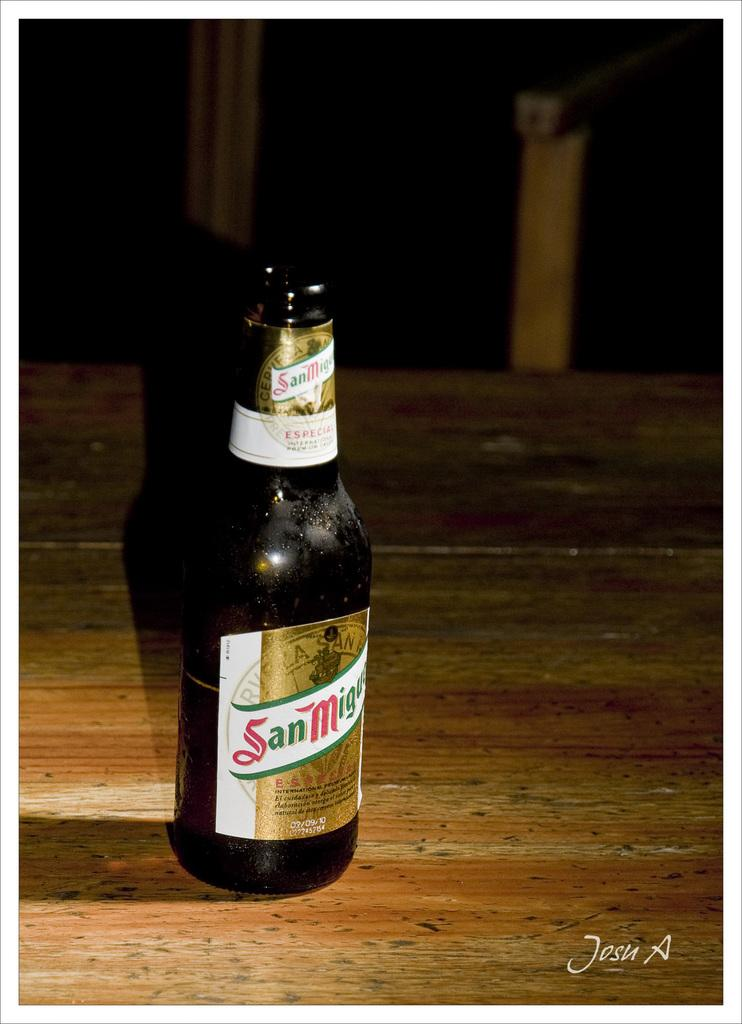<image>
Write a terse but informative summary of the picture. a beer says the word San on it 